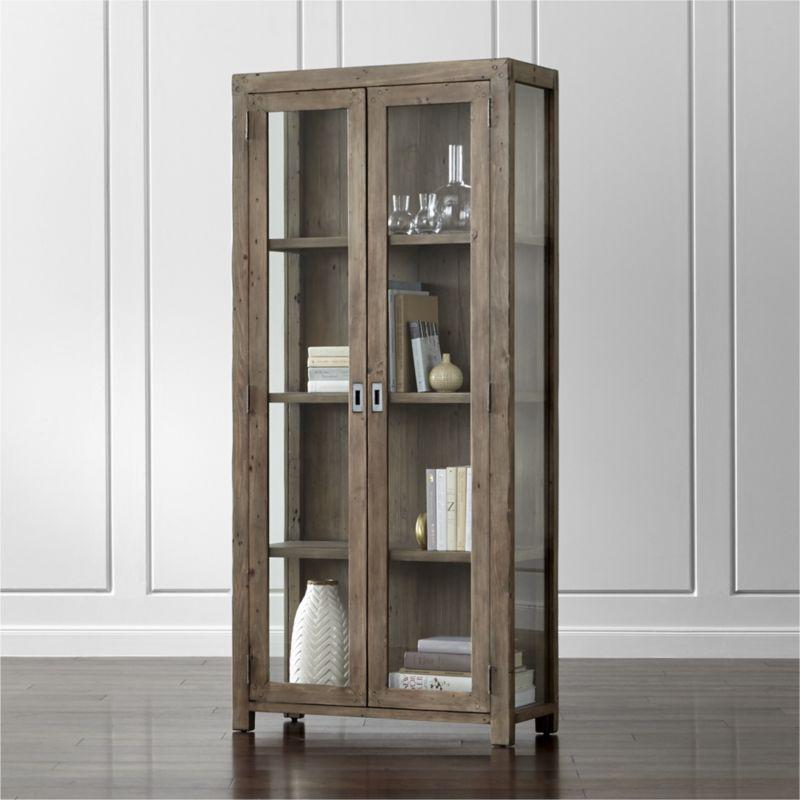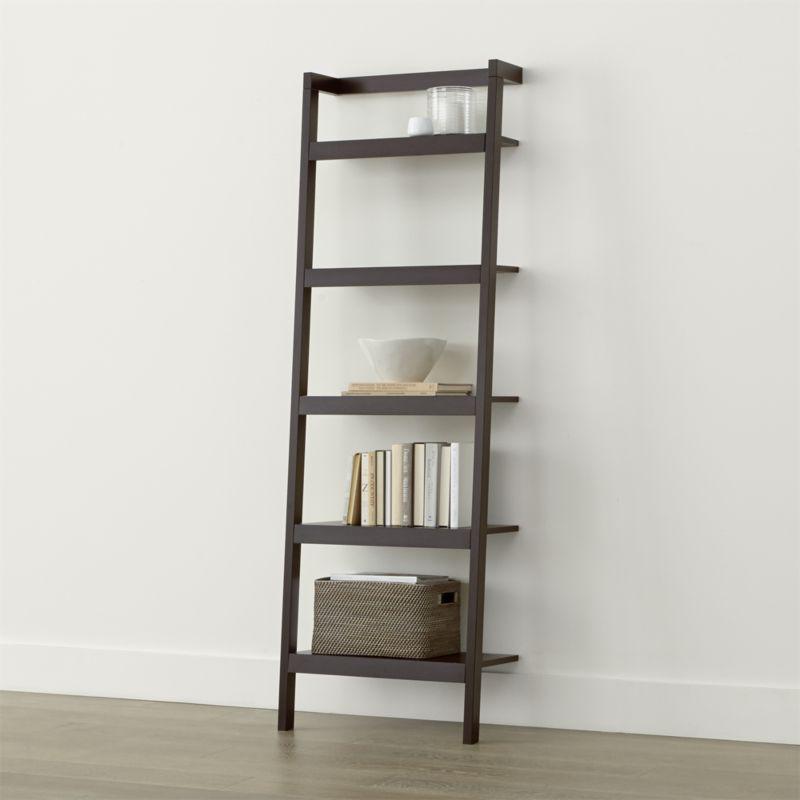The first image is the image on the left, the second image is the image on the right. Examine the images to the left and right. Is the description "At least one tall, narrow bookcase has closed double doors at the bottom." accurate? Answer yes or no. No. 